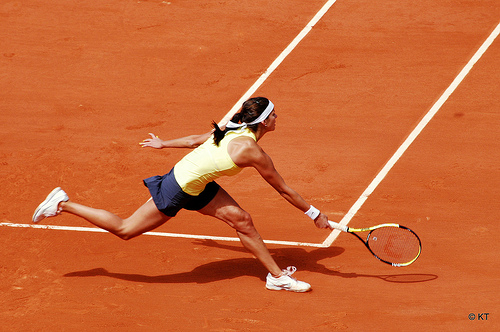Who wears a shirt? The player in the image is the one wearing a shirt. 